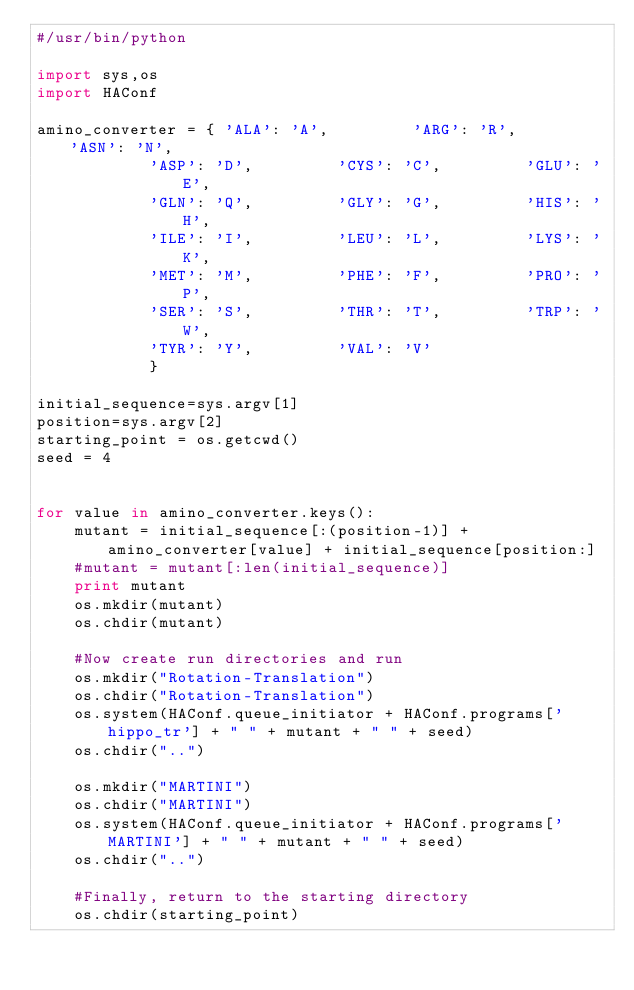<code> <loc_0><loc_0><loc_500><loc_500><_Python_>#/usr/bin/python

import sys,os
import HAConf

amino_converter = {	'ALA': 'A',			'ARG': 'R',			'ASN': 'N',
			'ASP': 'D',			'CYS': 'C',			'GLU': 'E',
			'GLN': 'Q',			'GLY': 'G',			'HIS': 'H',
			'ILE': 'I',			'LEU': 'L',			'LYS': 'K',
			'MET': 'M',			'PHE': 'F',			'PRO': 'P',
			'SER': 'S',			'THR': 'T',			'TRP': 'W',
			'TYR': 'Y',			'VAL': 'V'
			}

initial_sequence=sys.argv[1]
position=sys.argv[2]
starting_point = os.getcwd()
seed = 4


for value in amino_converter.keys():
	mutant = initial_sequence[:(position-1)] + amino_converter[value] + initial_sequence[position:]
	#mutant = mutant[:len(initial_sequence)]
	print mutant
	os.mkdir(mutant)
	os.chdir(mutant)
	
	#Now create run directories and run
	os.mkdir("Rotation-Translation")
	os.chdir("Rotation-Translation")
	os.system(HAConf.queue_initiator + HAConf.programs['hippo_tr'] + " " + mutant + " " + seed)
	os.chdir("..")
	
	os.mkdir("MARTINI")
	os.chdir("MARTINI")
	os.system(HAConf.queue_initiator + HAConf.programs['MARTINI'] + " " + mutant + " " + seed)
	os.chdir("..")
	
	#Finally, return to the starting directory
	os.chdir(starting_point)</code> 